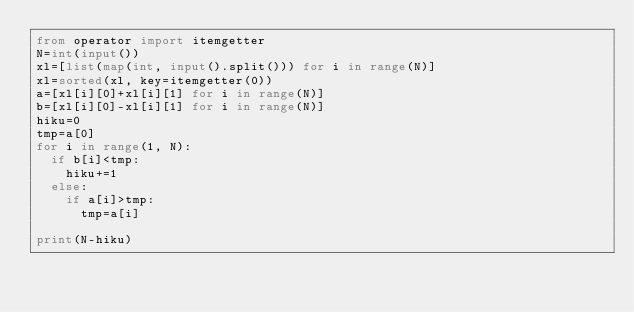<code> <loc_0><loc_0><loc_500><loc_500><_Python_>from operator import itemgetter
N=int(input())
xl=[list(map(int, input().split())) for i in range(N)]
xl=sorted(xl, key=itemgetter(0))
a=[xl[i][0]+xl[i][1] for i in range(N)]
b=[xl[i][0]-xl[i][1] for i in range(N)]
hiku=0
tmp=a[0]
for i in range(1, N):
  if b[i]<tmp:
    hiku+=1
  else:
    if a[i]>tmp:
      tmp=a[i]
      
print(N-hiku)</code> 